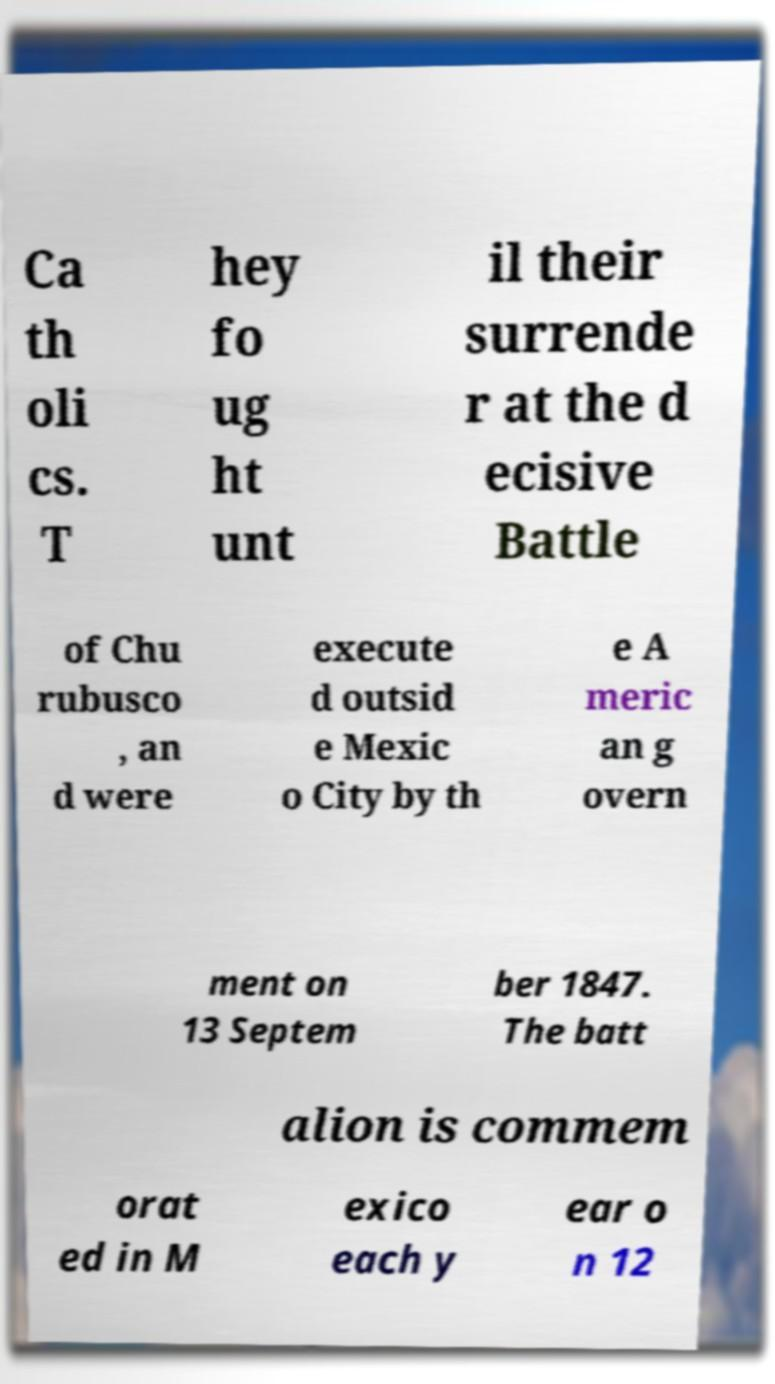Please identify and transcribe the text found in this image. Ca th oli cs. T hey fo ug ht unt il their surrende r at the d ecisive Battle of Chu rubusco , an d were execute d outsid e Mexic o City by th e A meric an g overn ment on 13 Septem ber 1847. The batt alion is commem orat ed in M exico each y ear o n 12 